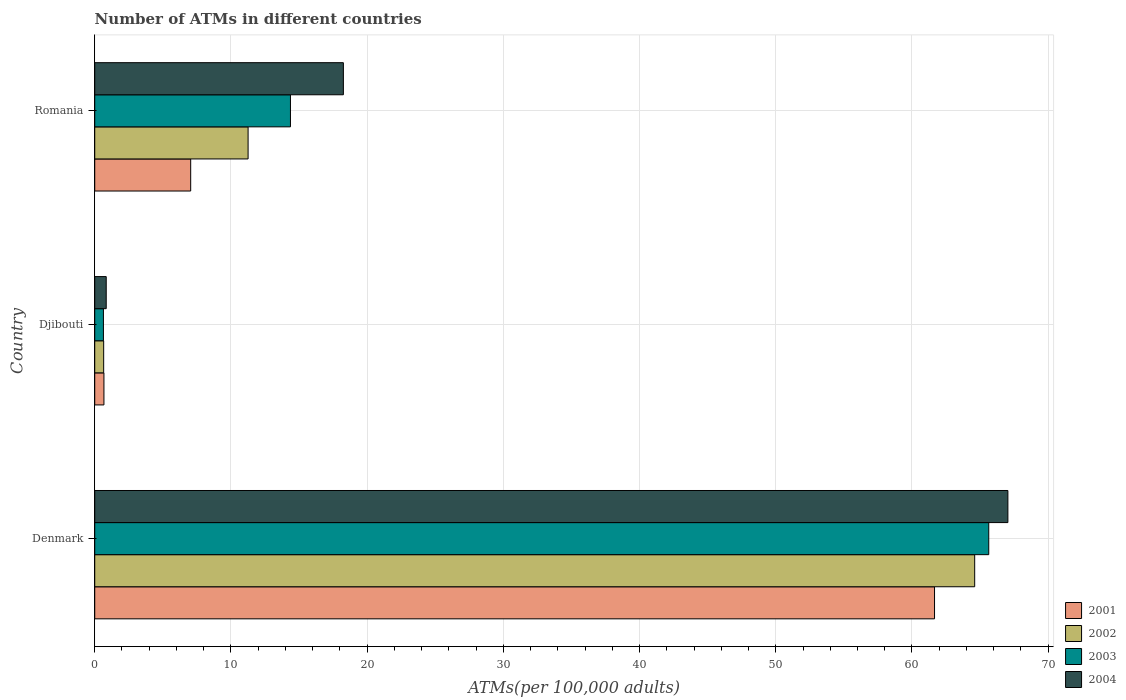How many groups of bars are there?
Your answer should be very brief. 3. Are the number of bars on each tick of the Y-axis equal?
Make the answer very short. Yes. How many bars are there on the 1st tick from the top?
Your answer should be compact. 4. In how many cases, is the number of bars for a given country not equal to the number of legend labels?
Give a very brief answer. 0. What is the number of ATMs in 2003 in Romania?
Your answer should be compact. 14.37. Across all countries, what is the maximum number of ATMs in 2004?
Provide a short and direct response. 67.04. Across all countries, what is the minimum number of ATMs in 2003?
Your response must be concise. 0.64. In which country was the number of ATMs in 2001 maximum?
Keep it short and to the point. Denmark. In which country was the number of ATMs in 2004 minimum?
Make the answer very short. Djibouti. What is the total number of ATMs in 2004 in the graph?
Your answer should be compact. 86.14. What is the difference between the number of ATMs in 2003 in Djibouti and that in Romania?
Give a very brief answer. -13.73. What is the difference between the number of ATMs in 2004 in Romania and the number of ATMs in 2003 in Djibouti?
Give a very brief answer. 17.62. What is the average number of ATMs in 2001 per country?
Your answer should be compact. 23.13. What is the difference between the number of ATMs in 2002 and number of ATMs in 2001 in Romania?
Provide a short and direct response. 4.21. What is the ratio of the number of ATMs in 2001 in Djibouti to that in Romania?
Give a very brief answer. 0.1. Is the difference between the number of ATMs in 2002 in Denmark and Romania greater than the difference between the number of ATMs in 2001 in Denmark and Romania?
Your response must be concise. No. What is the difference between the highest and the second highest number of ATMs in 2004?
Ensure brevity in your answer.  48.79. What is the difference between the highest and the lowest number of ATMs in 2001?
Keep it short and to the point. 60.98. Is the sum of the number of ATMs in 2002 in Denmark and Djibouti greater than the maximum number of ATMs in 2004 across all countries?
Provide a succinct answer. No. Is it the case that in every country, the sum of the number of ATMs in 2003 and number of ATMs in 2002 is greater than the sum of number of ATMs in 2004 and number of ATMs in 2001?
Your answer should be compact. No. What does the 3rd bar from the top in Djibouti represents?
Provide a short and direct response. 2002. What does the 4th bar from the bottom in Djibouti represents?
Provide a short and direct response. 2004. Is it the case that in every country, the sum of the number of ATMs in 2003 and number of ATMs in 2001 is greater than the number of ATMs in 2004?
Ensure brevity in your answer.  Yes. How many countries are there in the graph?
Keep it short and to the point. 3. Does the graph contain any zero values?
Your answer should be very brief. No. Where does the legend appear in the graph?
Keep it short and to the point. Bottom right. What is the title of the graph?
Offer a very short reply. Number of ATMs in different countries. Does "1963" appear as one of the legend labels in the graph?
Ensure brevity in your answer.  No. What is the label or title of the X-axis?
Provide a succinct answer. ATMs(per 100,0 adults). What is the label or title of the Y-axis?
Make the answer very short. Country. What is the ATMs(per 100,000 adults) in 2001 in Denmark?
Your answer should be compact. 61.66. What is the ATMs(per 100,000 adults) of 2002 in Denmark?
Provide a short and direct response. 64.61. What is the ATMs(per 100,000 adults) in 2003 in Denmark?
Keep it short and to the point. 65.64. What is the ATMs(per 100,000 adults) in 2004 in Denmark?
Your answer should be very brief. 67.04. What is the ATMs(per 100,000 adults) of 2001 in Djibouti?
Your response must be concise. 0.68. What is the ATMs(per 100,000 adults) of 2002 in Djibouti?
Keep it short and to the point. 0.66. What is the ATMs(per 100,000 adults) in 2003 in Djibouti?
Give a very brief answer. 0.64. What is the ATMs(per 100,000 adults) in 2004 in Djibouti?
Offer a very short reply. 0.84. What is the ATMs(per 100,000 adults) of 2001 in Romania?
Offer a terse response. 7.04. What is the ATMs(per 100,000 adults) of 2002 in Romania?
Your answer should be compact. 11.26. What is the ATMs(per 100,000 adults) of 2003 in Romania?
Make the answer very short. 14.37. What is the ATMs(per 100,000 adults) of 2004 in Romania?
Ensure brevity in your answer.  18.26. Across all countries, what is the maximum ATMs(per 100,000 adults) of 2001?
Provide a succinct answer. 61.66. Across all countries, what is the maximum ATMs(per 100,000 adults) of 2002?
Offer a terse response. 64.61. Across all countries, what is the maximum ATMs(per 100,000 adults) of 2003?
Give a very brief answer. 65.64. Across all countries, what is the maximum ATMs(per 100,000 adults) of 2004?
Your response must be concise. 67.04. Across all countries, what is the minimum ATMs(per 100,000 adults) in 2001?
Your response must be concise. 0.68. Across all countries, what is the minimum ATMs(per 100,000 adults) of 2002?
Provide a succinct answer. 0.66. Across all countries, what is the minimum ATMs(per 100,000 adults) of 2003?
Your response must be concise. 0.64. Across all countries, what is the minimum ATMs(per 100,000 adults) of 2004?
Your answer should be very brief. 0.84. What is the total ATMs(per 100,000 adults) of 2001 in the graph?
Provide a succinct answer. 69.38. What is the total ATMs(per 100,000 adults) of 2002 in the graph?
Ensure brevity in your answer.  76.52. What is the total ATMs(per 100,000 adults) of 2003 in the graph?
Provide a short and direct response. 80.65. What is the total ATMs(per 100,000 adults) of 2004 in the graph?
Ensure brevity in your answer.  86.14. What is the difference between the ATMs(per 100,000 adults) in 2001 in Denmark and that in Djibouti?
Ensure brevity in your answer.  60.98. What is the difference between the ATMs(per 100,000 adults) in 2002 in Denmark and that in Djibouti?
Your answer should be very brief. 63.95. What is the difference between the ATMs(per 100,000 adults) of 2003 in Denmark and that in Djibouti?
Provide a short and direct response. 65. What is the difference between the ATMs(per 100,000 adults) in 2004 in Denmark and that in Djibouti?
Your answer should be very brief. 66.2. What is the difference between the ATMs(per 100,000 adults) in 2001 in Denmark and that in Romania?
Give a very brief answer. 54.61. What is the difference between the ATMs(per 100,000 adults) in 2002 in Denmark and that in Romania?
Provide a short and direct response. 53.35. What is the difference between the ATMs(per 100,000 adults) in 2003 in Denmark and that in Romania?
Make the answer very short. 51.27. What is the difference between the ATMs(per 100,000 adults) of 2004 in Denmark and that in Romania?
Ensure brevity in your answer.  48.79. What is the difference between the ATMs(per 100,000 adults) in 2001 in Djibouti and that in Romania?
Provide a succinct answer. -6.37. What is the difference between the ATMs(per 100,000 adults) of 2002 in Djibouti and that in Romania?
Offer a very short reply. -10.6. What is the difference between the ATMs(per 100,000 adults) in 2003 in Djibouti and that in Romania?
Provide a short and direct response. -13.73. What is the difference between the ATMs(per 100,000 adults) of 2004 in Djibouti and that in Romania?
Give a very brief answer. -17.41. What is the difference between the ATMs(per 100,000 adults) of 2001 in Denmark and the ATMs(per 100,000 adults) of 2002 in Djibouti?
Your answer should be compact. 61. What is the difference between the ATMs(per 100,000 adults) in 2001 in Denmark and the ATMs(per 100,000 adults) in 2003 in Djibouti?
Give a very brief answer. 61.02. What is the difference between the ATMs(per 100,000 adults) in 2001 in Denmark and the ATMs(per 100,000 adults) in 2004 in Djibouti?
Offer a very short reply. 60.81. What is the difference between the ATMs(per 100,000 adults) in 2002 in Denmark and the ATMs(per 100,000 adults) in 2003 in Djibouti?
Provide a short and direct response. 63.97. What is the difference between the ATMs(per 100,000 adults) in 2002 in Denmark and the ATMs(per 100,000 adults) in 2004 in Djibouti?
Provide a short and direct response. 63.76. What is the difference between the ATMs(per 100,000 adults) in 2003 in Denmark and the ATMs(per 100,000 adults) in 2004 in Djibouti?
Provide a short and direct response. 64.79. What is the difference between the ATMs(per 100,000 adults) of 2001 in Denmark and the ATMs(per 100,000 adults) of 2002 in Romania?
Your answer should be compact. 50.4. What is the difference between the ATMs(per 100,000 adults) of 2001 in Denmark and the ATMs(per 100,000 adults) of 2003 in Romania?
Offer a terse response. 47.29. What is the difference between the ATMs(per 100,000 adults) of 2001 in Denmark and the ATMs(per 100,000 adults) of 2004 in Romania?
Ensure brevity in your answer.  43.4. What is the difference between the ATMs(per 100,000 adults) in 2002 in Denmark and the ATMs(per 100,000 adults) in 2003 in Romania?
Offer a very short reply. 50.24. What is the difference between the ATMs(per 100,000 adults) of 2002 in Denmark and the ATMs(per 100,000 adults) of 2004 in Romania?
Your answer should be very brief. 46.35. What is the difference between the ATMs(per 100,000 adults) in 2003 in Denmark and the ATMs(per 100,000 adults) in 2004 in Romania?
Your answer should be compact. 47.38. What is the difference between the ATMs(per 100,000 adults) in 2001 in Djibouti and the ATMs(per 100,000 adults) in 2002 in Romania?
Your response must be concise. -10.58. What is the difference between the ATMs(per 100,000 adults) of 2001 in Djibouti and the ATMs(per 100,000 adults) of 2003 in Romania?
Your response must be concise. -13.69. What is the difference between the ATMs(per 100,000 adults) in 2001 in Djibouti and the ATMs(per 100,000 adults) in 2004 in Romania?
Provide a succinct answer. -17.58. What is the difference between the ATMs(per 100,000 adults) of 2002 in Djibouti and the ATMs(per 100,000 adults) of 2003 in Romania?
Provide a succinct answer. -13.71. What is the difference between the ATMs(per 100,000 adults) of 2002 in Djibouti and the ATMs(per 100,000 adults) of 2004 in Romania?
Make the answer very short. -17.6. What is the difference between the ATMs(per 100,000 adults) in 2003 in Djibouti and the ATMs(per 100,000 adults) in 2004 in Romania?
Keep it short and to the point. -17.62. What is the average ATMs(per 100,000 adults) of 2001 per country?
Your response must be concise. 23.13. What is the average ATMs(per 100,000 adults) in 2002 per country?
Offer a terse response. 25.51. What is the average ATMs(per 100,000 adults) in 2003 per country?
Give a very brief answer. 26.88. What is the average ATMs(per 100,000 adults) in 2004 per country?
Make the answer very short. 28.71. What is the difference between the ATMs(per 100,000 adults) of 2001 and ATMs(per 100,000 adults) of 2002 in Denmark?
Make the answer very short. -2.95. What is the difference between the ATMs(per 100,000 adults) of 2001 and ATMs(per 100,000 adults) of 2003 in Denmark?
Make the answer very short. -3.98. What is the difference between the ATMs(per 100,000 adults) of 2001 and ATMs(per 100,000 adults) of 2004 in Denmark?
Your answer should be very brief. -5.39. What is the difference between the ATMs(per 100,000 adults) of 2002 and ATMs(per 100,000 adults) of 2003 in Denmark?
Ensure brevity in your answer.  -1.03. What is the difference between the ATMs(per 100,000 adults) in 2002 and ATMs(per 100,000 adults) in 2004 in Denmark?
Provide a succinct answer. -2.44. What is the difference between the ATMs(per 100,000 adults) in 2003 and ATMs(per 100,000 adults) in 2004 in Denmark?
Give a very brief answer. -1.41. What is the difference between the ATMs(per 100,000 adults) of 2001 and ATMs(per 100,000 adults) of 2002 in Djibouti?
Provide a succinct answer. 0.02. What is the difference between the ATMs(per 100,000 adults) of 2001 and ATMs(per 100,000 adults) of 2003 in Djibouti?
Provide a short and direct response. 0.04. What is the difference between the ATMs(per 100,000 adults) in 2001 and ATMs(per 100,000 adults) in 2004 in Djibouti?
Make the answer very short. -0.17. What is the difference between the ATMs(per 100,000 adults) in 2002 and ATMs(per 100,000 adults) in 2003 in Djibouti?
Make the answer very short. 0.02. What is the difference between the ATMs(per 100,000 adults) of 2002 and ATMs(per 100,000 adults) of 2004 in Djibouti?
Your answer should be compact. -0.19. What is the difference between the ATMs(per 100,000 adults) in 2003 and ATMs(per 100,000 adults) in 2004 in Djibouti?
Your answer should be compact. -0.21. What is the difference between the ATMs(per 100,000 adults) of 2001 and ATMs(per 100,000 adults) of 2002 in Romania?
Provide a short and direct response. -4.21. What is the difference between the ATMs(per 100,000 adults) in 2001 and ATMs(per 100,000 adults) in 2003 in Romania?
Provide a succinct answer. -7.32. What is the difference between the ATMs(per 100,000 adults) of 2001 and ATMs(per 100,000 adults) of 2004 in Romania?
Your response must be concise. -11.21. What is the difference between the ATMs(per 100,000 adults) in 2002 and ATMs(per 100,000 adults) in 2003 in Romania?
Offer a very short reply. -3.11. What is the difference between the ATMs(per 100,000 adults) in 2002 and ATMs(per 100,000 adults) in 2004 in Romania?
Make the answer very short. -7. What is the difference between the ATMs(per 100,000 adults) of 2003 and ATMs(per 100,000 adults) of 2004 in Romania?
Make the answer very short. -3.89. What is the ratio of the ATMs(per 100,000 adults) in 2001 in Denmark to that in Djibouti?
Keep it short and to the point. 91.18. What is the ratio of the ATMs(per 100,000 adults) in 2002 in Denmark to that in Djibouti?
Give a very brief answer. 98.45. What is the ratio of the ATMs(per 100,000 adults) in 2003 in Denmark to that in Djibouti?
Keep it short and to the point. 102.88. What is the ratio of the ATMs(per 100,000 adults) in 2004 in Denmark to that in Djibouti?
Keep it short and to the point. 79.46. What is the ratio of the ATMs(per 100,000 adults) in 2001 in Denmark to that in Romania?
Your response must be concise. 8.75. What is the ratio of the ATMs(per 100,000 adults) in 2002 in Denmark to that in Romania?
Your answer should be compact. 5.74. What is the ratio of the ATMs(per 100,000 adults) in 2003 in Denmark to that in Romania?
Keep it short and to the point. 4.57. What is the ratio of the ATMs(per 100,000 adults) in 2004 in Denmark to that in Romania?
Make the answer very short. 3.67. What is the ratio of the ATMs(per 100,000 adults) of 2001 in Djibouti to that in Romania?
Provide a short and direct response. 0.1. What is the ratio of the ATMs(per 100,000 adults) in 2002 in Djibouti to that in Romania?
Ensure brevity in your answer.  0.06. What is the ratio of the ATMs(per 100,000 adults) of 2003 in Djibouti to that in Romania?
Your response must be concise. 0.04. What is the ratio of the ATMs(per 100,000 adults) in 2004 in Djibouti to that in Romania?
Your answer should be compact. 0.05. What is the difference between the highest and the second highest ATMs(per 100,000 adults) of 2001?
Offer a terse response. 54.61. What is the difference between the highest and the second highest ATMs(per 100,000 adults) in 2002?
Provide a short and direct response. 53.35. What is the difference between the highest and the second highest ATMs(per 100,000 adults) of 2003?
Provide a succinct answer. 51.27. What is the difference between the highest and the second highest ATMs(per 100,000 adults) in 2004?
Provide a succinct answer. 48.79. What is the difference between the highest and the lowest ATMs(per 100,000 adults) of 2001?
Provide a short and direct response. 60.98. What is the difference between the highest and the lowest ATMs(per 100,000 adults) in 2002?
Give a very brief answer. 63.95. What is the difference between the highest and the lowest ATMs(per 100,000 adults) in 2003?
Make the answer very short. 65. What is the difference between the highest and the lowest ATMs(per 100,000 adults) in 2004?
Your answer should be compact. 66.2. 